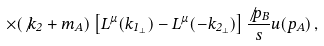Convert formula to latex. <formula><loc_0><loc_0><loc_500><loc_500>\times ( \not { k } _ { 2 } + m _ { A } ) \left [ L ^ { \mu } ( k _ { 1 _ { \perp } } ) - L ^ { \mu } ( - k _ { 2 _ { \perp } } ) \right ] \frac { \not { p } _ { B } } { s } u ( p _ { A } ) \, ,</formula> 